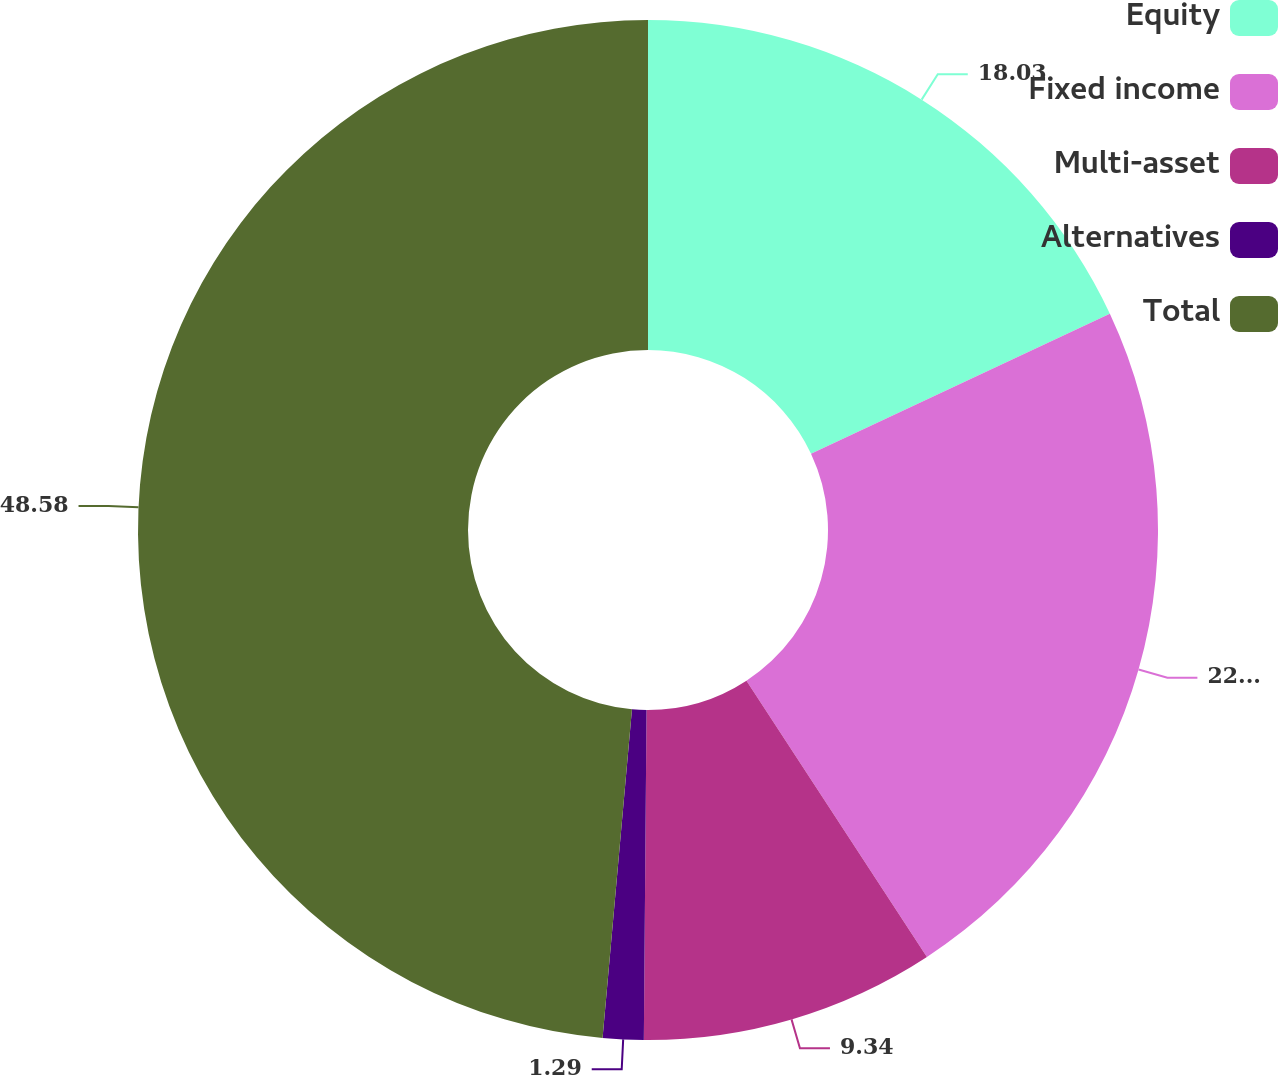Convert chart. <chart><loc_0><loc_0><loc_500><loc_500><pie_chart><fcel>Equity<fcel>Fixed income<fcel>Multi-asset<fcel>Alternatives<fcel>Total<nl><fcel>18.03%<fcel>22.76%<fcel>9.34%<fcel>1.29%<fcel>48.58%<nl></chart> 